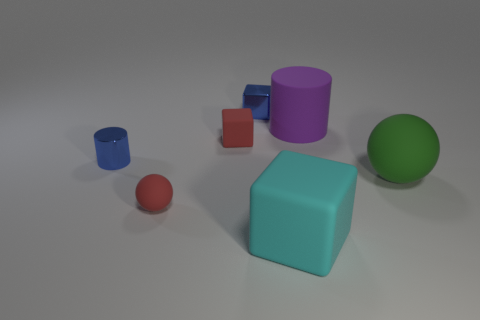Add 1 red blocks. How many objects exist? 8 Subtract all cylinders. How many objects are left? 5 Subtract all tiny purple balls. Subtract all small red rubber things. How many objects are left? 5 Add 6 big cyan matte cubes. How many big cyan matte cubes are left? 7 Add 7 yellow matte spheres. How many yellow matte spheres exist? 7 Subtract 0 blue spheres. How many objects are left? 7 